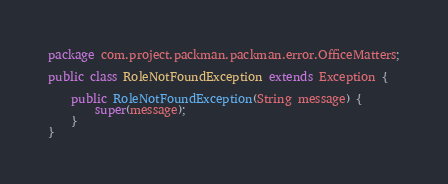Convert code to text. <code><loc_0><loc_0><loc_500><loc_500><_Java_>package com.project.packman.packman.error.OfficeMatters;

public class RoleNotFoundException extends Exception {

    public RoleNotFoundException(String message) {
        super(message);
    }
}
</code> 